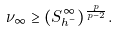<formula> <loc_0><loc_0><loc_500><loc_500>\nu _ { \infty } \geq ( S ^ { \infty } _ { h ^ { - } } ) ^ { \frac { p } { p - 2 } } .</formula> 